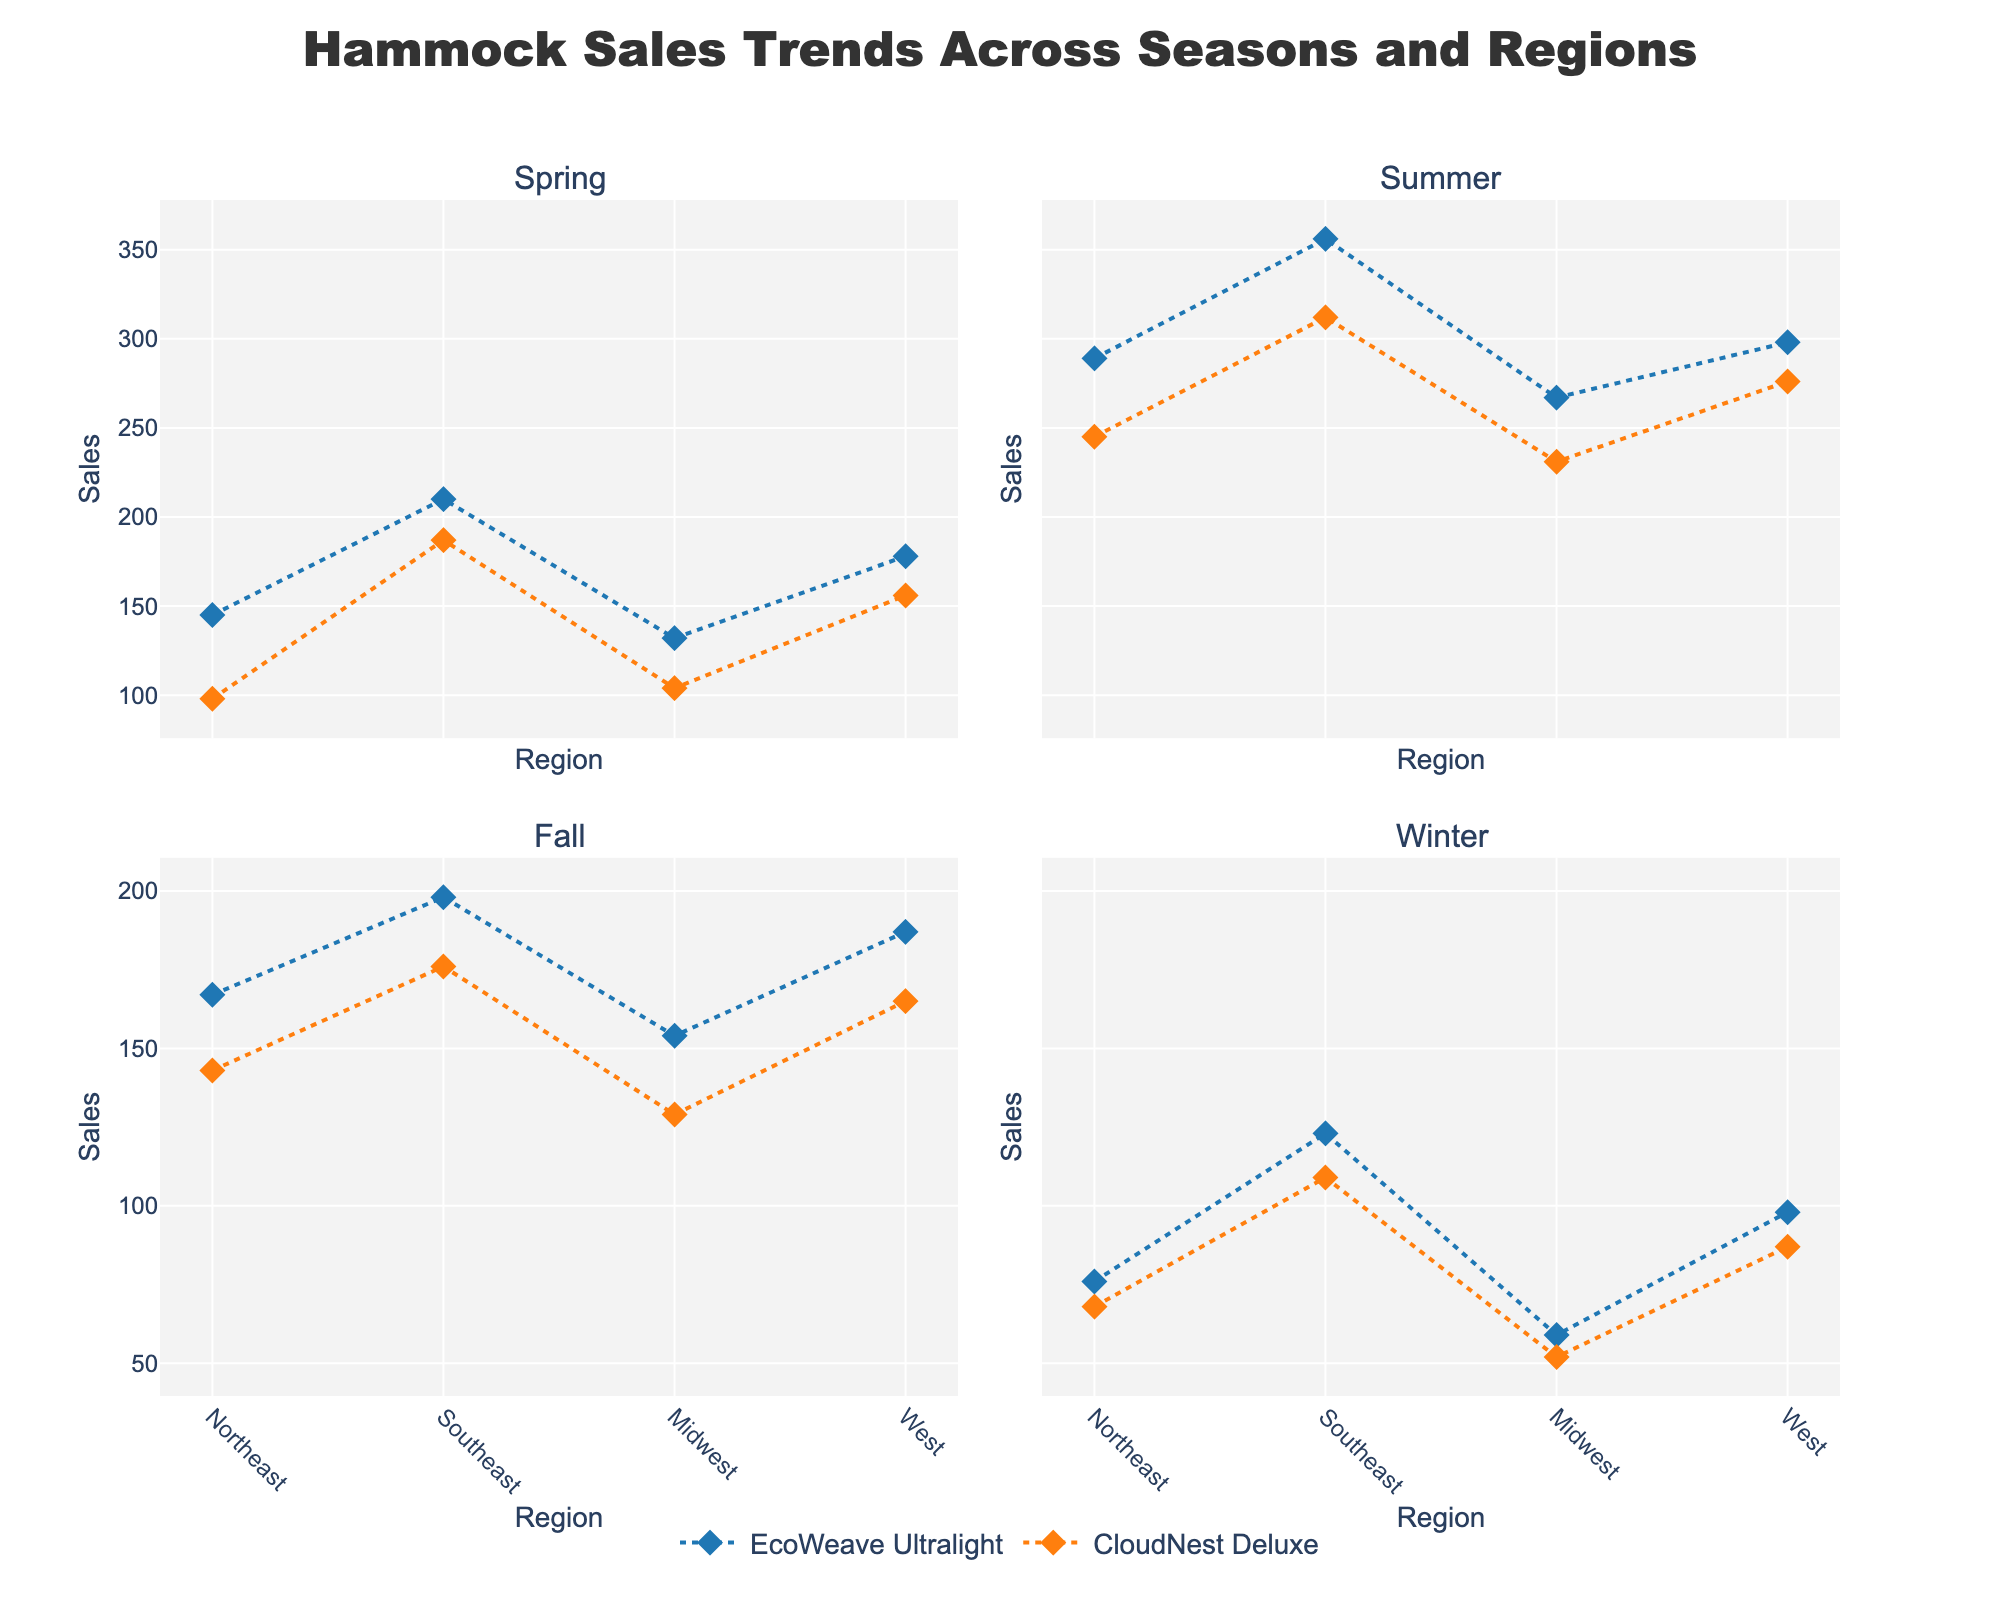What is the title of the figure? The title is written at the top center of the figure. It reads "Hammock Sales Trends Across Seasons and Regions."
Answer: Hammock Sales Trends Across Seasons and Regions Which season shows the highest sales for the 'EcoWeave Ultralight' model? By looking at the y-axis values across all subplots, the highest sales for 'EcoWeave Ultralight' model appear in the Summer season.
Answer: Summer How do the sales of 'CloudNest Deluxe' in the Midwest differ between Spring and Fall? For the Midwest region, find the sales of 'CloudNest Deluxe' in both Spring (104) and Fall (129) from the respective subplots and calculate the difference (129 - 104).
Answer: 25 In which region and season do 'EcoWeave Ultralight' sales exceed 300 units? Locate points on the y-axis that exceed 300 in the subplot for each season, and check the regions. It's only in the Summer subplot (Southeast region).
Answer: Southeast, Summer Which model shows a consistent downward trend in sales from Summer to Winter across all regions? Examine the sales trends for both models from Summer to Winter across each region within the subplots. 'EcoWeave Ultralight' shows a consistent downward trend in all regions.
Answer: EcoWeave Ultralight What are the average sales of 'CloudNest Deluxe' in the Winter season across all regions? Collect the sales numbers for 'CloudNest Deluxe' in Winter (68, 109, 52, 87), add them up (316), and divide by the number of regions (4).
Answer: 79 How does the sales trend for 'CloudNest Deluxe' compare between Northeast and West in the Fall season? Compare the y-axis values representing sales for 'CloudNest Deluxe' in the Northeast (143) and West (165) regions within the Fall subplot. The sales in the West are higher than in the Northeast.
Answer: West > Northeast Based on the figure, which season has the lowest overall sales for both models combined? Sum up sales for both models across all regions in each season. Winter has the lowest combined sales.
Answer: Winter How do the sales patterns of 'EcoWeave Ultralight' differ between the Southeast and Midwest regions over the seasons? Observe and compare changes in y-axis values for 'EcoWeave Ultralight' between Southeast and Midwest subplots across seasons. The Southeast consistently has higher sales than the Midwest.
Answer: Southeast > Midwest 